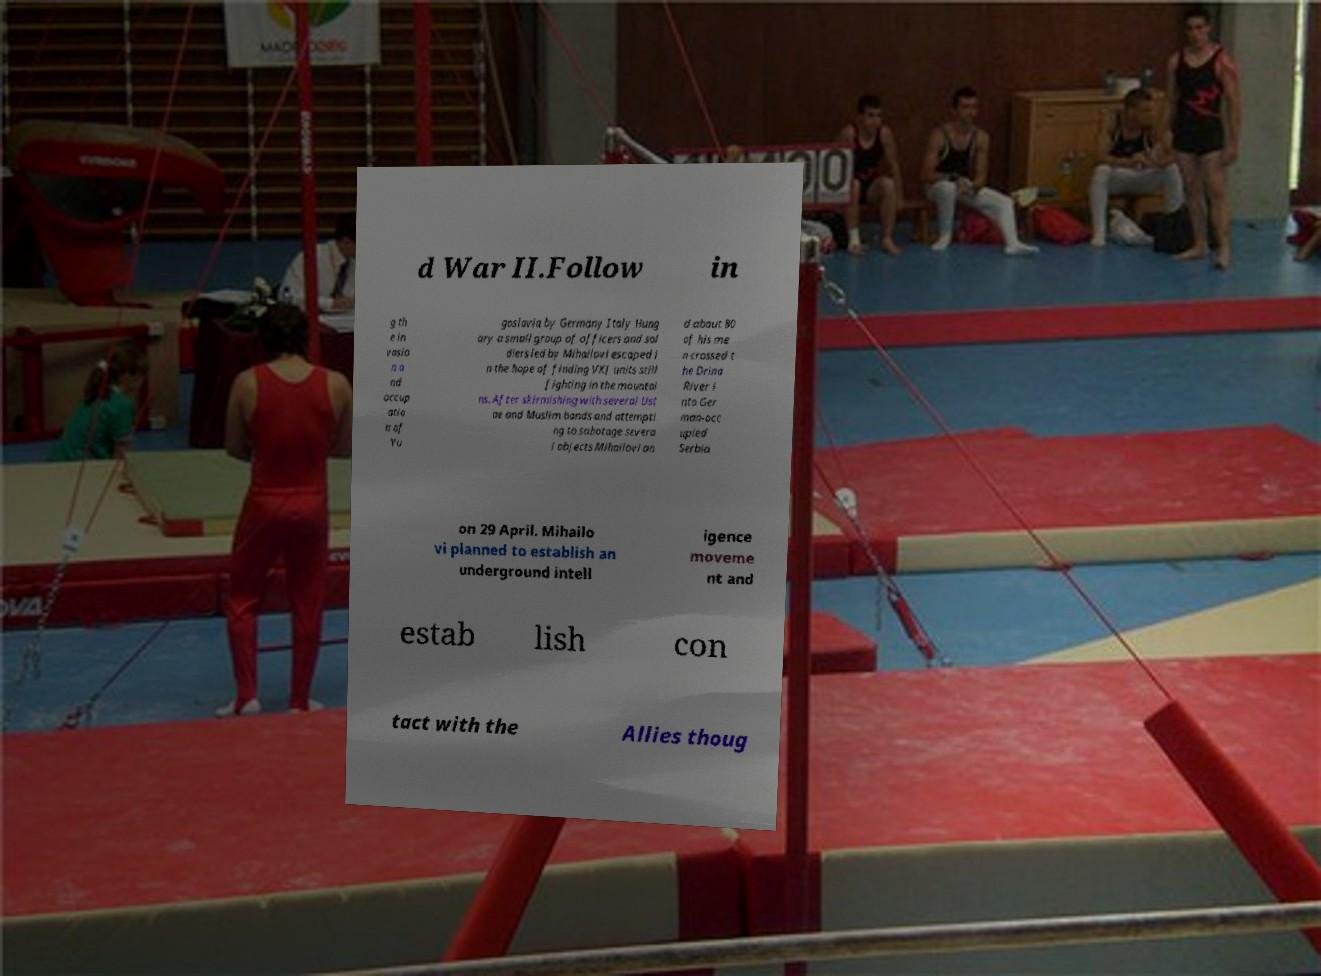Can you read and provide the text displayed in the image?This photo seems to have some interesting text. Can you extract and type it out for me? d War II.Follow in g th e in vasio n a nd occup atio n of Yu goslavia by Germany Italy Hung ary a small group of officers and sol diers led by Mihailovi escaped i n the hope of finding VKJ units still fighting in the mountai ns. After skirmishing with several Ust ae and Muslim bands and attempti ng to sabotage severa l objects Mihailovi an d about 80 of his me n crossed t he Drina River i nto Ger man-occ upied Serbia on 29 April. Mihailo vi planned to establish an underground intell igence moveme nt and estab lish con tact with the Allies thoug 